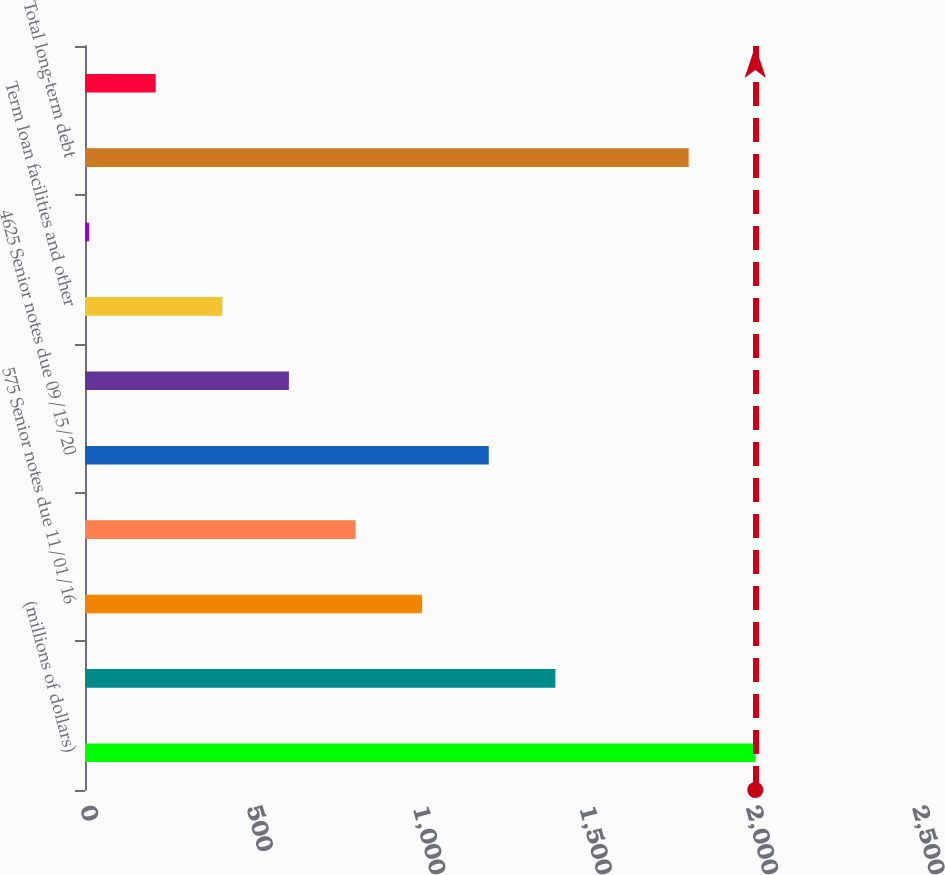Convert chart. <chart><loc_0><loc_0><loc_500><loc_500><bar_chart><fcel>(millions of dollars)<fcel>Short-term borrowings<fcel>575 Senior notes due 11/01/16<fcel>800 Senior notes due 10/01/19<fcel>4625 Senior notes due 09/15/20<fcel>7125 Senior notes due 02/15/29<fcel>Term loan facilities and other<fcel>Impact of derivatives on debt<fcel>Total long-term debt<fcel>Less current portion<nl><fcel>2014<fcel>1413.43<fcel>1013.05<fcel>812.86<fcel>1213.24<fcel>612.67<fcel>412.48<fcel>12.1<fcel>1813.81<fcel>212.29<nl></chart> 